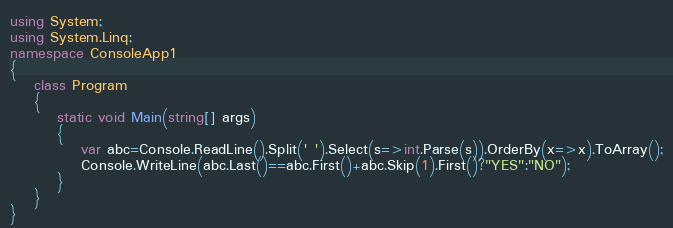<code> <loc_0><loc_0><loc_500><loc_500><_C#_>using System;
using System.Linq;
namespace ConsoleApp1
{
    class Program
    {
        static void Main(string[] args)
        {
            var abc=Console.ReadLine().Split(' ').Select(s=>int.Parse(s)).OrderBy(x=>x).ToArray();
            Console.WriteLine(abc.Last()==abc.First()+abc.Skip(1).First()?"YES":"NO");
        }
    }
}
</code> 